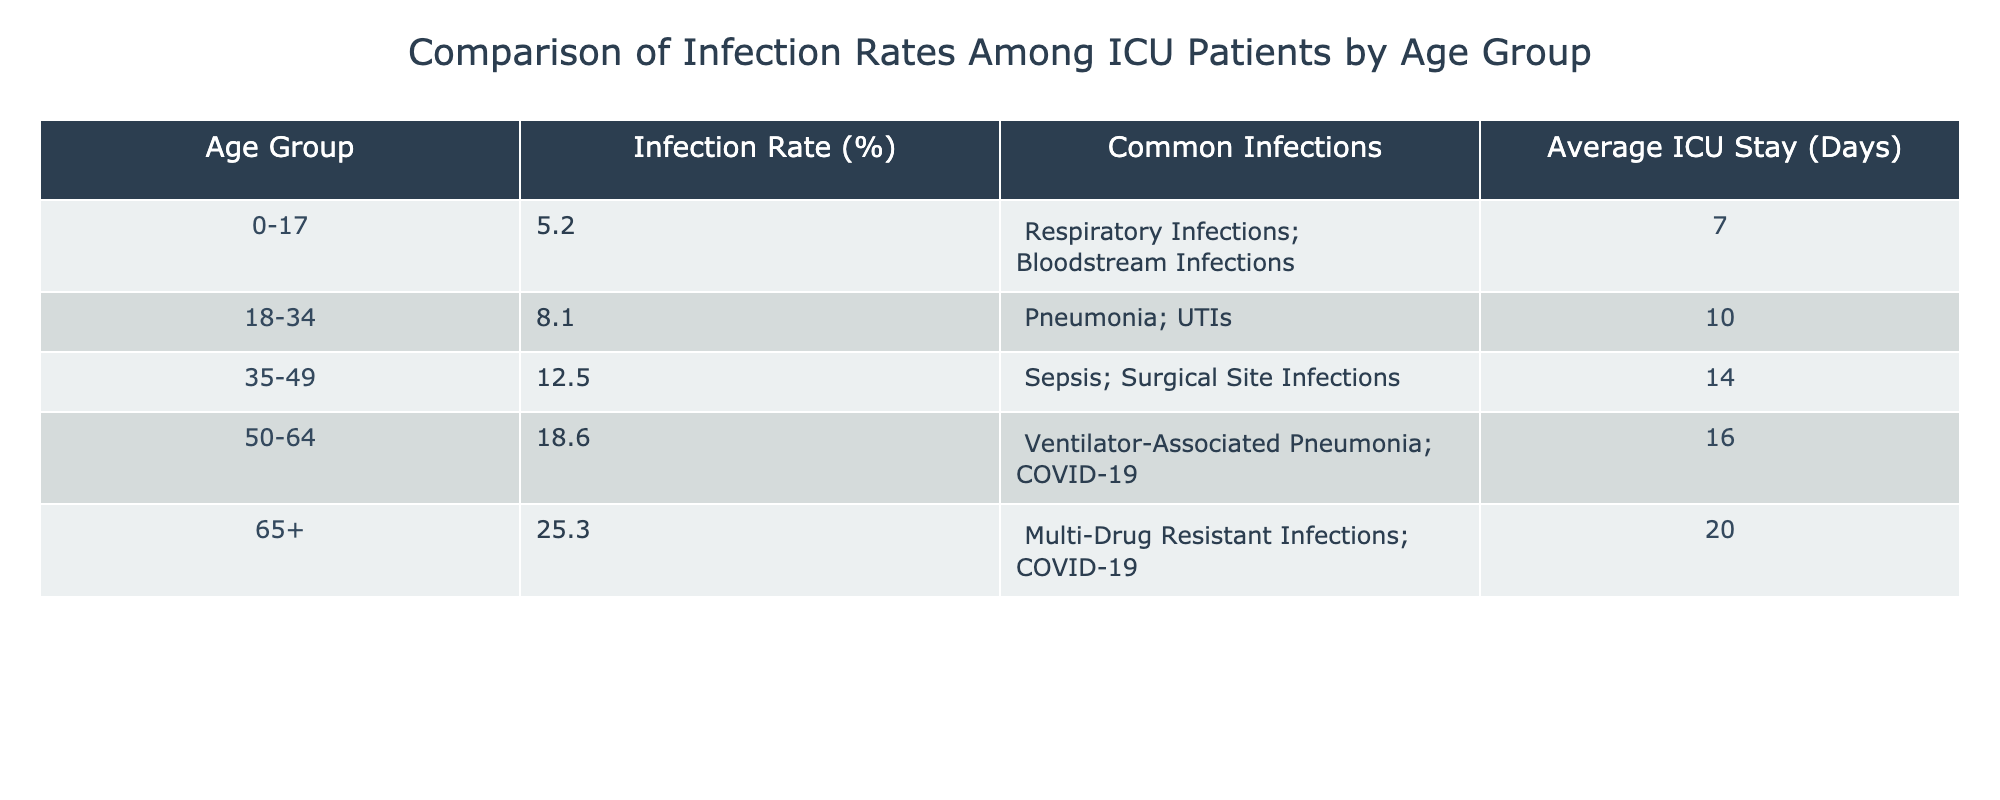What is the infection rate for the age group 50-64? According to the table, the infection rate listed for the age group 50-64 is 18.6%.
Answer: 18.6% Which age group has the highest infection rate? The table shows that the age group 65+ has the highest infection rate at 25.3%.
Answer: 65+ How many days, on average, do patients aged 35-49 stay in the ICU? From the table, the average ICU stay for patients aged 35-49 is 14 days.
Answer: 14 days What is the average infection rate across all age groups? The infection rates for each group are: 5.2%, 8.1%, 12.5%, 18.6%, and 25.3%. Adding these gives 69.7%. There are 5 groups, so the average infection rate is 69.7% / 5 = 13.94%.
Answer: 13.94% Do patients aged 0-17 have a higher average ICU stay than those aged 18-34? The table indicates that patients aged 0-17 have an average ICU stay of 7 days, while those aged 18-34 stay for 10 days. Hence, the statement is false because 7 days is less than 10 days.
Answer: No How much higher is the infection rate for the 65+ age group compared to the 0-17 age group? The infection rate for the 65+ age group is 25.3%, and for the 0-17 age group, it is 5.2%. The difference is 25.3% - 5.2% = 20.1%.
Answer: 20.1% Are respiratory infections common among patients aged 35-49? According to the table, the common infections for the 35-49 age group include sepsis and surgical site infections, with respiratory infections not mentioned. Therefore, the statement is false.
Answer: No What is the total number of common infections listed for the age group 50-64? For the age group 50-64, the common infections listed are ventilator-associated pneumonia and COVID-19, totaling 2 infections.
Answer: 2 Which age group has the longest average ICU stay? The table specifies that the age group 65+ has an average ICU stay of 20 days, which is longer than any other age group's average stay listed in the table.
Answer: 65+ 